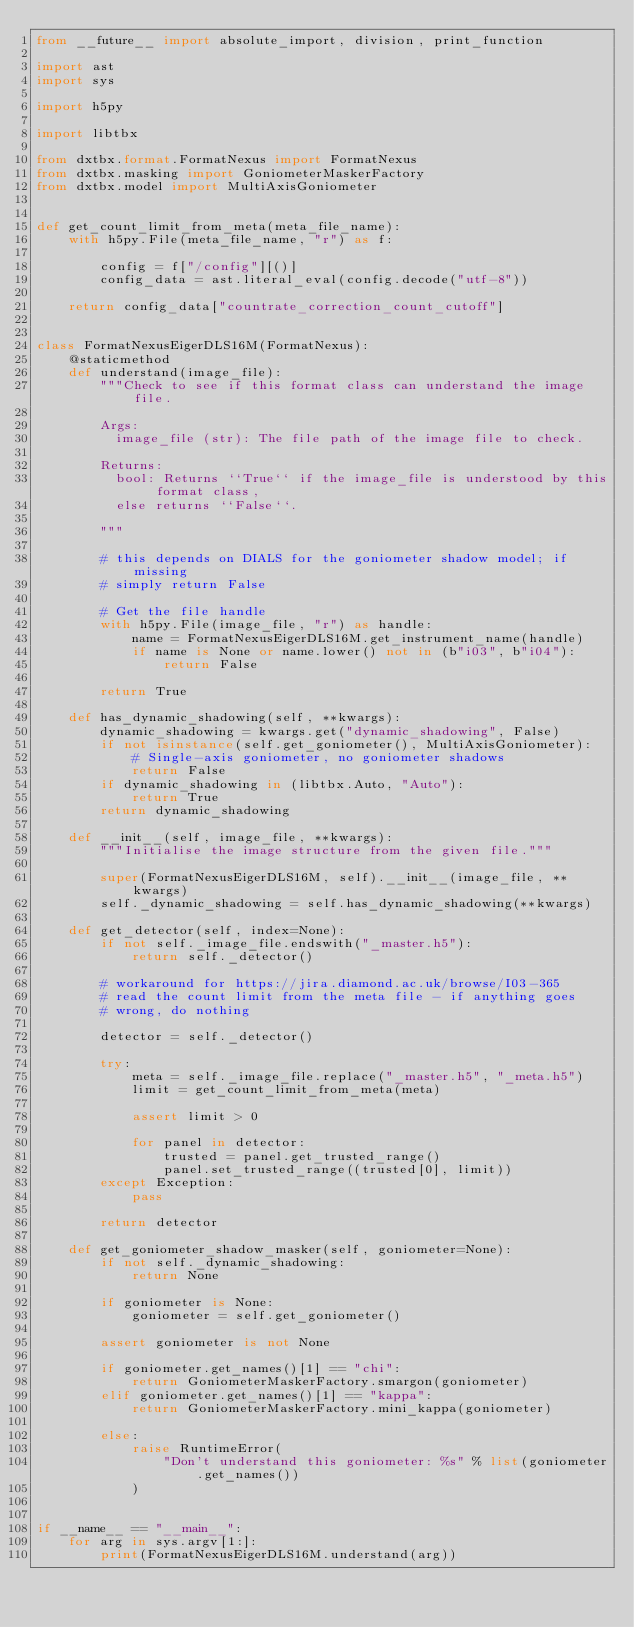<code> <loc_0><loc_0><loc_500><loc_500><_Python_>from __future__ import absolute_import, division, print_function

import ast
import sys

import h5py

import libtbx

from dxtbx.format.FormatNexus import FormatNexus
from dxtbx.masking import GoniometerMaskerFactory
from dxtbx.model import MultiAxisGoniometer


def get_count_limit_from_meta(meta_file_name):
    with h5py.File(meta_file_name, "r") as f:

        config = f["/config"][()]
        config_data = ast.literal_eval(config.decode("utf-8"))

    return config_data["countrate_correction_count_cutoff"]


class FormatNexusEigerDLS16M(FormatNexus):
    @staticmethod
    def understand(image_file):
        """Check to see if this format class can understand the image file.

        Args:
          image_file (str): The file path of the image file to check.

        Returns:
          bool: Returns ``True`` if the image_file is understood by this format class,
          else returns ``False``.

        """

        # this depends on DIALS for the goniometer shadow model; if missing
        # simply return False

        # Get the file handle
        with h5py.File(image_file, "r") as handle:
            name = FormatNexusEigerDLS16M.get_instrument_name(handle)
            if name is None or name.lower() not in (b"i03", b"i04"):
                return False

        return True

    def has_dynamic_shadowing(self, **kwargs):
        dynamic_shadowing = kwargs.get("dynamic_shadowing", False)
        if not isinstance(self.get_goniometer(), MultiAxisGoniometer):
            # Single-axis goniometer, no goniometer shadows
            return False
        if dynamic_shadowing in (libtbx.Auto, "Auto"):
            return True
        return dynamic_shadowing

    def __init__(self, image_file, **kwargs):
        """Initialise the image structure from the given file."""

        super(FormatNexusEigerDLS16M, self).__init__(image_file, **kwargs)
        self._dynamic_shadowing = self.has_dynamic_shadowing(**kwargs)

    def get_detector(self, index=None):
        if not self._image_file.endswith("_master.h5"):
            return self._detector()

        # workaround for https://jira.diamond.ac.uk/browse/I03-365
        # read the count limit from the meta file - if anything goes
        # wrong, do nothing

        detector = self._detector()

        try:
            meta = self._image_file.replace("_master.h5", "_meta.h5")
            limit = get_count_limit_from_meta(meta)

            assert limit > 0

            for panel in detector:
                trusted = panel.get_trusted_range()
                panel.set_trusted_range((trusted[0], limit))
        except Exception:
            pass

        return detector

    def get_goniometer_shadow_masker(self, goniometer=None):
        if not self._dynamic_shadowing:
            return None

        if goniometer is None:
            goniometer = self.get_goniometer()

        assert goniometer is not None

        if goniometer.get_names()[1] == "chi":
            return GoniometerMaskerFactory.smargon(goniometer)
        elif goniometer.get_names()[1] == "kappa":
            return GoniometerMaskerFactory.mini_kappa(goniometer)

        else:
            raise RuntimeError(
                "Don't understand this goniometer: %s" % list(goniometer.get_names())
            )


if __name__ == "__main__":
    for arg in sys.argv[1:]:
        print(FormatNexusEigerDLS16M.understand(arg))
</code> 